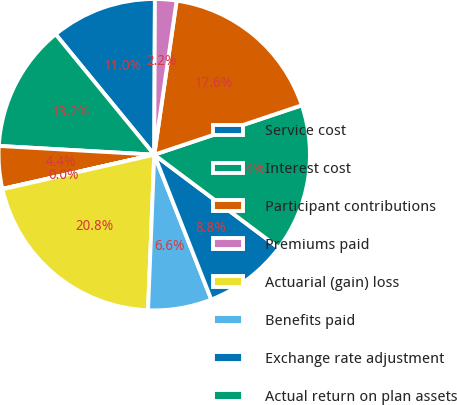<chart> <loc_0><loc_0><loc_500><loc_500><pie_chart><fcel>Service cost<fcel>Interest cost<fcel>Participant contributions<fcel>Premiums paid<fcel>Actuarial (gain) loss<fcel>Benefits paid<fcel>Exchange rate adjustment<fcel>Actual return on plan assets<fcel>Employer contributions<fcel>Current liabilities<nl><fcel>10.99%<fcel>13.18%<fcel>4.42%<fcel>0.04%<fcel>20.8%<fcel>6.61%<fcel>8.8%<fcel>15.37%<fcel>17.56%<fcel>2.23%<nl></chart> 